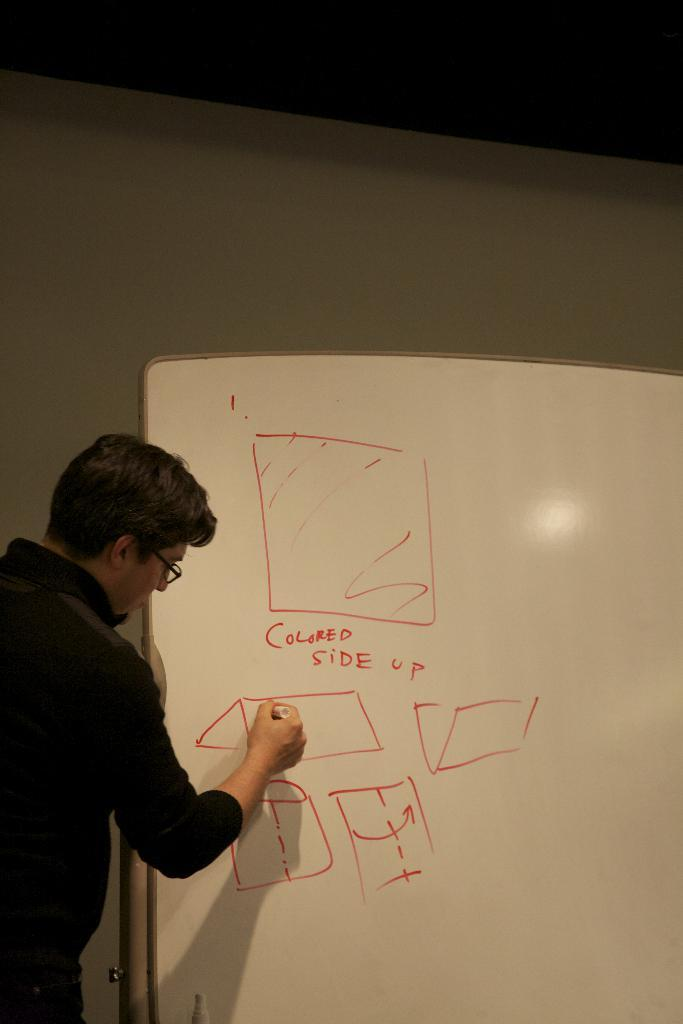Provide a one-sentence caption for the provided image. A man writes on a white board that has colored side up written in red. 